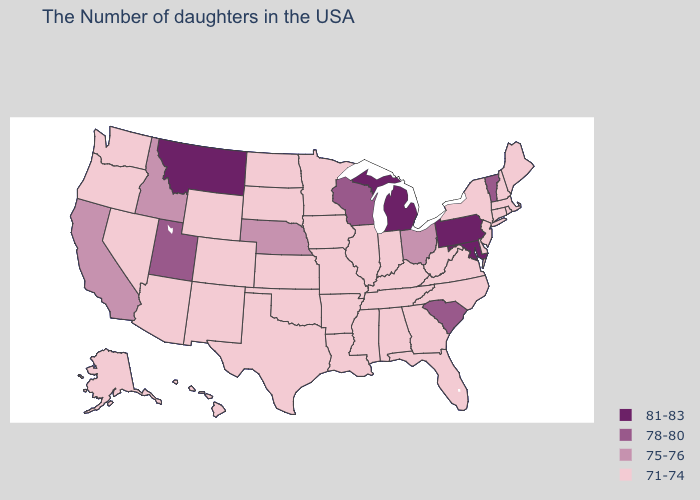Does Kansas have the lowest value in the USA?
Concise answer only. Yes. Which states have the lowest value in the USA?
Keep it brief. Maine, Massachusetts, Rhode Island, New Hampshire, Connecticut, New York, New Jersey, Delaware, Virginia, North Carolina, West Virginia, Florida, Georgia, Kentucky, Indiana, Alabama, Tennessee, Illinois, Mississippi, Louisiana, Missouri, Arkansas, Minnesota, Iowa, Kansas, Oklahoma, Texas, South Dakota, North Dakota, Wyoming, Colorado, New Mexico, Arizona, Nevada, Washington, Oregon, Alaska, Hawaii. Name the states that have a value in the range 75-76?
Concise answer only. Ohio, Nebraska, Idaho, California. What is the lowest value in states that border New Jersey?
Quick response, please. 71-74. Name the states that have a value in the range 71-74?
Be succinct. Maine, Massachusetts, Rhode Island, New Hampshire, Connecticut, New York, New Jersey, Delaware, Virginia, North Carolina, West Virginia, Florida, Georgia, Kentucky, Indiana, Alabama, Tennessee, Illinois, Mississippi, Louisiana, Missouri, Arkansas, Minnesota, Iowa, Kansas, Oklahoma, Texas, South Dakota, North Dakota, Wyoming, Colorado, New Mexico, Arizona, Nevada, Washington, Oregon, Alaska, Hawaii. Does Michigan have the highest value in the USA?
Concise answer only. Yes. Name the states that have a value in the range 75-76?
Short answer required. Ohio, Nebraska, Idaho, California. Among the states that border New Hampshire , which have the lowest value?
Short answer required. Maine, Massachusetts. Which states have the lowest value in the South?
Write a very short answer. Delaware, Virginia, North Carolina, West Virginia, Florida, Georgia, Kentucky, Alabama, Tennessee, Mississippi, Louisiana, Arkansas, Oklahoma, Texas. Name the states that have a value in the range 75-76?
Write a very short answer. Ohio, Nebraska, Idaho, California. Does Michigan have the highest value in the USA?
Write a very short answer. Yes. What is the value of Arkansas?
Keep it brief. 71-74. Does North Dakota have the same value as South Carolina?
Concise answer only. No. 